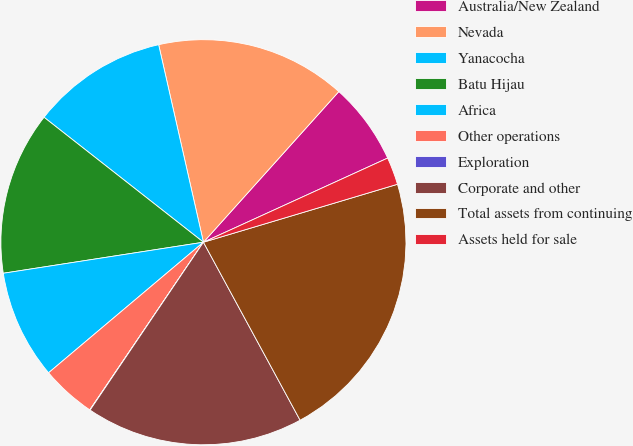Convert chart to OTSL. <chart><loc_0><loc_0><loc_500><loc_500><pie_chart><fcel>Australia/New Zealand<fcel>Nevada<fcel>Yanacocha<fcel>Batu Hijau<fcel>Africa<fcel>Other operations<fcel>Exploration<fcel>Corporate and other<fcel>Total assets from continuing<fcel>Assets held for sale<nl><fcel>6.53%<fcel>15.2%<fcel>10.87%<fcel>13.03%<fcel>8.7%<fcel>4.37%<fcel>0.03%<fcel>17.37%<fcel>21.7%<fcel>2.2%<nl></chart> 